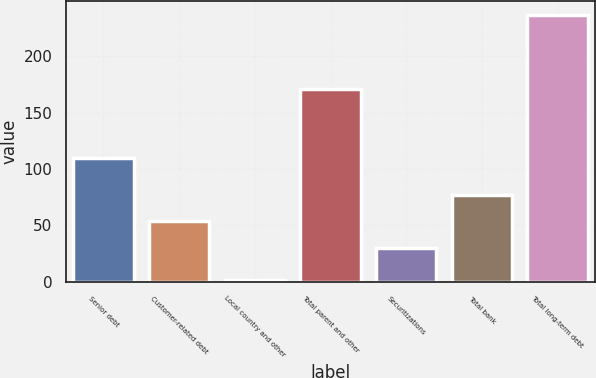<chart> <loc_0><loc_0><loc_500><loc_500><bar_chart><fcel>Senior debt<fcel>Customer-related debt<fcel>Local country and other<fcel>Total parent and other<fcel>Securitizations<fcel>Total bank<fcel>Total long-term debt<nl><fcel>109.8<fcel>53.79<fcel>1.8<fcel>170.9<fcel>30.3<fcel>77.28<fcel>236.7<nl></chart> 